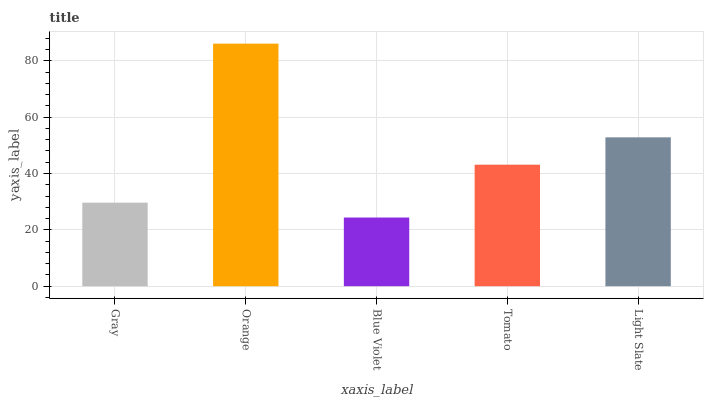Is Blue Violet the minimum?
Answer yes or no. Yes. Is Orange the maximum?
Answer yes or no. Yes. Is Orange the minimum?
Answer yes or no. No. Is Blue Violet the maximum?
Answer yes or no. No. Is Orange greater than Blue Violet?
Answer yes or no. Yes. Is Blue Violet less than Orange?
Answer yes or no. Yes. Is Blue Violet greater than Orange?
Answer yes or no. No. Is Orange less than Blue Violet?
Answer yes or no. No. Is Tomato the high median?
Answer yes or no. Yes. Is Tomato the low median?
Answer yes or no. Yes. Is Orange the high median?
Answer yes or no. No. Is Gray the low median?
Answer yes or no. No. 